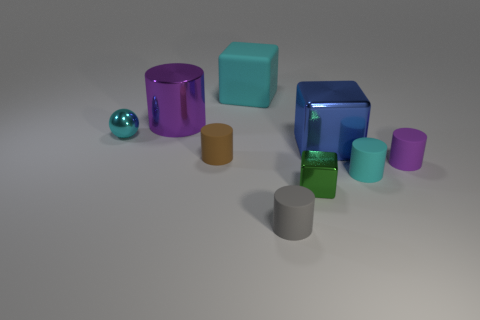Do the cyan block and the cyan cylinder have the same material? yes 